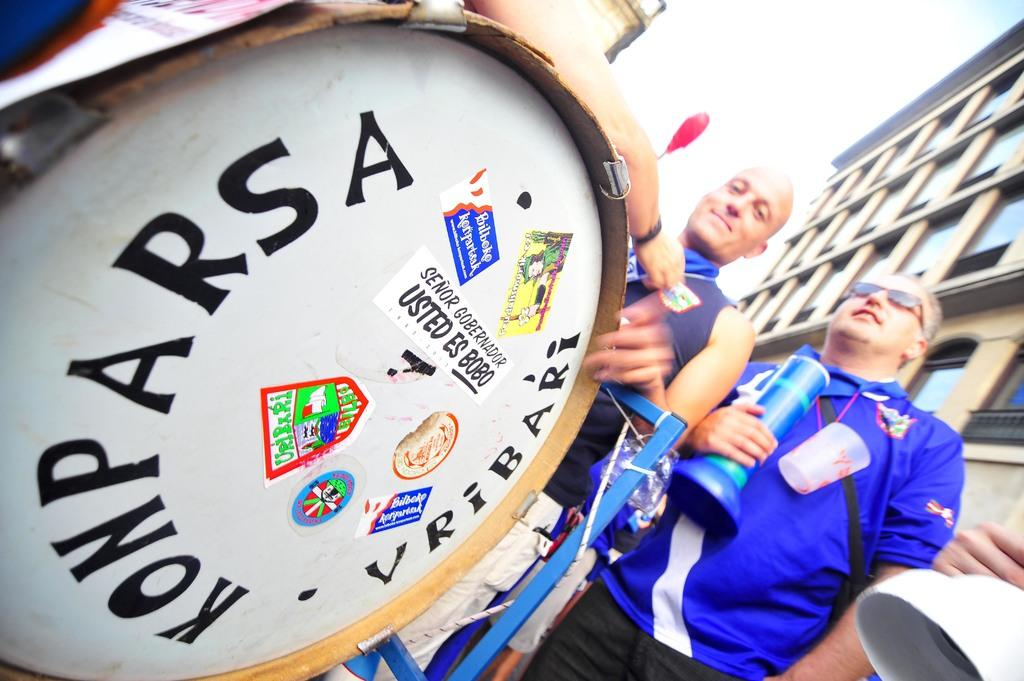How many people are present in the image? There are two people in the image. What else can be seen in the image besides the people? There is a band in the image. Can you see a kitty playing with a ball of yarn in the image? There is no kitty or ball of yarn present in the image. 